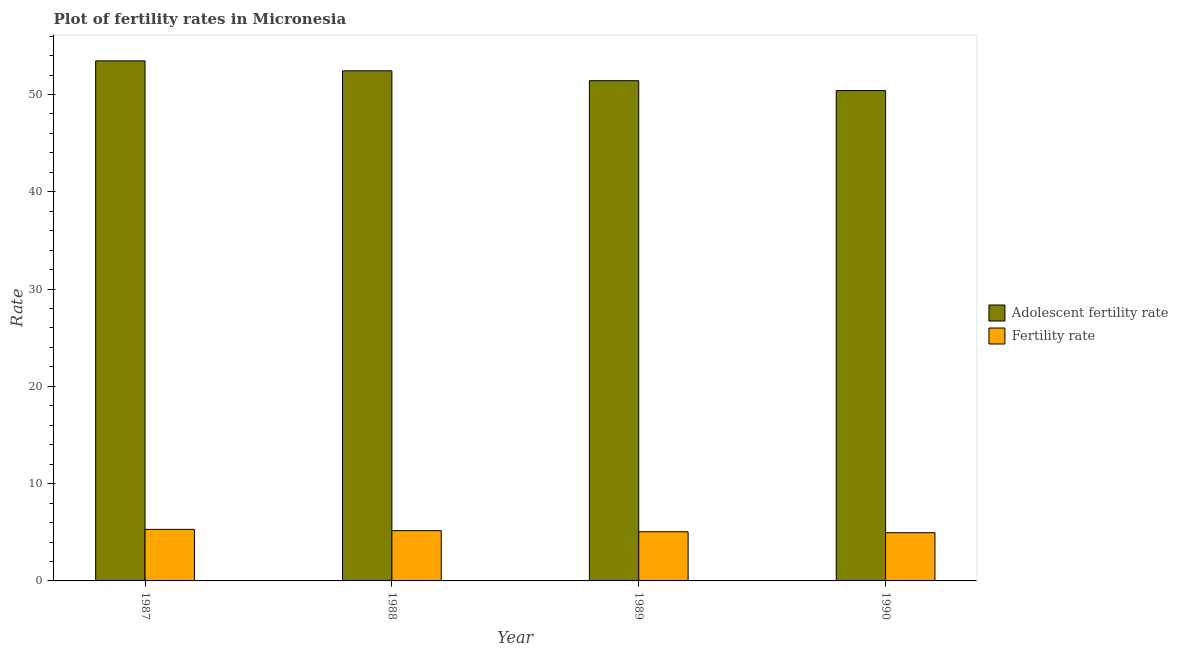Are the number of bars on each tick of the X-axis equal?
Your answer should be compact. Yes. What is the label of the 2nd group of bars from the left?
Offer a very short reply. 1988. What is the adolescent fertility rate in 1987?
Offer a very short reply. 53.46. Across all years, what is the maximum fertility rate?
Offer a terse response. 5.3. Across all years, what is the minimum fertility rate?
Your answer should be compact. 4.96. In which year was the fertility rate maximum?
Offer a terse response. 1987. What is the total fertility rate in the graph?
Keep it short and to the point. 20.48. What is the difference between the adolescent fertility rate in 1989 and that in 1990?
Provide a short and direct response. 1.02. What is the difference between the fertility rate in 1987 and the adolescent fertility rate in 1989?
Offer a very short reply. 0.25. What is the average adolescent fertility rate per year?
Your answer should be compact. 51.93. In the year 1990, what is the difference between the fertility rate and adolescent fertility rate?
Give a very brief answer. 0. What is the ratio of the fertility rate in 1988 to that in 1989?
Make the answer very short. 1.02. Is the difference between the fertility rate in 1988 and 1990 greater than the difference between the adolescent fertility rate in 1988 and 1990?
Provide a succinct answer. No. What is the difference between the highest and the second highest fertility rate?
Your answer should be compact. 0.13. What is the difference between the highest and the lowest adolescent fertility rate?
Your answer should be very brief. 3.06. In how many years, is the adolescent fertility rate greater than the average adolescent fertility rate taken over all years?
Give a very brief answer. 2. What does the 1st bar from the left in 1989 represents?
Give a very brief answer. Adolescent fertility rate. What does the 2nd bar from the right in 1990 represents?
Ensure brevity in your answer.  Adolescent fertility rate. How many bars are there?
Your answer should be compact. 8. What is the difference between two consecutive major ticks on the Y-axis?
Provide a short and direct response. 10. Does the graph contain grids?
Your response must be concise. No. Where does the legend appear in the graph?
Provide a succinct answer. Center right. How many legend labels are there?
Ensure brevity in your answer.  2. How are the legend labels stacked?
Offer a terse response. Vertical. What is the title of the graph?
Your response must be concise. Plot of fertility rates in Micronesia. What is the label or title of the X-axis?
Your answer should be compact. Year. What is the label or title of the Y-axis?
Ensure brevity in your answer.  Rate. What is the Rate of Adolescent fertility rate in 1987?
Offer a very short reply. 53.46. What is the Rate in Fertility rate in 1987?
Your answer should be compact. 5.3. What is the Rate in Adolescent fertility rate in 1988?
Make the answer very short. 52.44. What is the Rate in Fertility rate in 1988?
Provide a succinct answer. 5.17. What is the Rate in Adolescent fertility rate in 1989?
Your answer should be compact. 51.42. What is the Rate in Fertility rate in 1989?
Provide a succinct answer. 5.05. What is the Rate in Adolescent fertility rate in 1990?
Provide a succinct answer. 50.4. What is the Rate in Fertility rate in 1990?
Make the answer very short. 4.96. Across all years, what is the maximum Rate of Adolescent fertility rate?
Your answer should be compact. 53.46. Across all years, what is the maximum Rate in Fertility rate?
Offer a very short reply. 5.3. Across all years, what is the minimum Rate in Adolescent fertility rate?
Keep it short and to the point. 50.4. Across all years, what is the minimum Rate of Fertility rate?
Your response must be concise. 4.96. What is the total Rate of Adolescent fertility rate in the graph?
Ensure brevity in your answer.  207.71. What is the total Rate of Fertility rate in the graph?
Keep it short and to the point. 20.48. What is the difference between the Rate of Adolescent fertility rate in 1987 and that in 1988?
Offer a very short reply. 1.02. What is the difference between the Rate in Fertility rate in 1987 and that in 1988?
Offer a very short reply. 0.13. What is the difference between the Rate in Adolescent fertility rate in 1987 and that in 1989?
Your answer should be very brief. 2.04. What is the difference between the Rate in Fertility rate in 1987 and that in 1989?
Make the answer very short. 0.25. What is the difference between the Rate of Adolescent fertility rate in 1987 and that in 1990?
Your response must be concise. 3.06. What is the difference between the Rate of Fertility rate in 1987 and that in 1990?
Keep it short and to the point. 0.34. What is the difference between the Rate of Adolescent fertility rate in 1988 and that in 1989?
Offer a terse response. 1.02. What is the difference between the Rate in Fertility rate in 1988 and that in 1989?
Give a very brief answer. 0.12. What is the difference between the Rate of Adolescent fertility rate in 1988 and that in 1990?
Offer a very short reply. 2.04. What is the difference between the Rate in Fertility rate in 1988 and that in 1990?
Provide a succinct answer. 0.21. What is the difference between the Rate of Adolescent fertility rate in 1989 and that in 1990?
Your answer should be very brief. 1.02. What is the difference between the Rate in Fertility rate in 1989 and that in 1990?
Offer a very short reply. 0.09. What is the difference between the Rate in Adolescent fertility rate in 1987 and the Rate in Fertility rate in 1988?
Provide a succinct answer. 48.29. What is the difference between the Rate of Adolescent fertility rate in 1987 and the Rate of Fertility rate in 1989?
Offer a terse response. 48.4. What is the difference between the Rate of Adolescent fertility rate in 1987 and the Rate of Fertility rate in 1990?
Ensure brevity in your answer.  48.5. What is the difference between the Rate of Adolescent fertility rate in 1988 and the Rate of Fertility rate in 1989?
Your answer should be compact. 47.39. What is the difference between the Rate in Adolescent fertility rate in 1988 and the Rate in Fertility rate in 1990?
Offer a terse response. 47.48. What is the difference between the Rate in Adolescent fertility rate in 1989 and the Rate in Fertility rate in 1990?
Ensure brevity in your answer.  46.46. What is the average Rate of Adolescent fertility rate per year?
Your response must be concise. 51.93. What is the average Rate of Fertility rate per year?
Ensure brevity in your answer.  5.12. In the year 1987, what is the difference between the Rate of Adolescent fertility rate and Rate of Fertility rate?
Ensure brevity in your answer.  48.16. In the year 1988, what is the difference between the Rate of Adolescent fertility rate and Rate of Fertility rate?
Your answer should be very brief. 47.27. In the year 1989, what is the difference between the Rate in Adolescent fertility rate and Rate in Fertility rate?
Provide a succinct answer. 46.37. In the year 1990, what is the difference between the Rate in Adolescent fertility rate and Rate in Fertility rate?
Make the answer very short. 45.44. What is the ratio of the Rate in Adolescent fertility rate in 1987 to that in 1988?
Your answer should be compact. 1.02. What is the ratio of the Rate in Fertility rate in 1987 to that in 1988?
Keep it short and to the point. 1.03. What is the ratio of the Rate of Adolescent fertility rate in 1987 to that in 1989?
Your answer should be compact. 1.04. What is the ratio of the Rate in Fertility rate in 1987 to that in 1989?
Ensure brevity in your answer.  1.05. What is the ratio of the Rate in Adolescent fertility rate in 1987 to that in 1990?
Your answer should be compact. 1.06. What is the ratio of the Rate in Fertility rate in 1987 to that in 1990?
Offer a very short reply. 1.07. What is the ratio of the Rate of Adolescent fertility rate in 1988 to that in 1989?
Offer a very short reply. 1.02. What is the ratio of the Rate of Fertility rate in 1988 to that in 1989?
Keep it short and to the point. 1.02. What is the ratio of the Rate of Adolescent fertility rate in 1988 to that in 1990?
Make the answer very short. 1.04. What is the ratio of the Rate of Fertility rate in 1988 to that in 1990?
Offer a very short reply. 1.04. What is the ratio of the Rate in Adolescent fertility rate in 1989 to that in 1990?
Offer a very short reply. 1.02. What is the difference between the highest and the second highest Rate of Adolescent fertility rate?
Provide a short and direct response. 1.02. What is the difference between the highest and the second highest Rate in Fertility rate?
Your answer should be very brief. 0.13. What is the difference between the highest and the lowest Rate of Adolescent fertility rate?
Offer a terse response. 3.06. What is the difference between the highest and the lowest Rate of Fertility rate?
Your answer should be very brief. 0.34. 